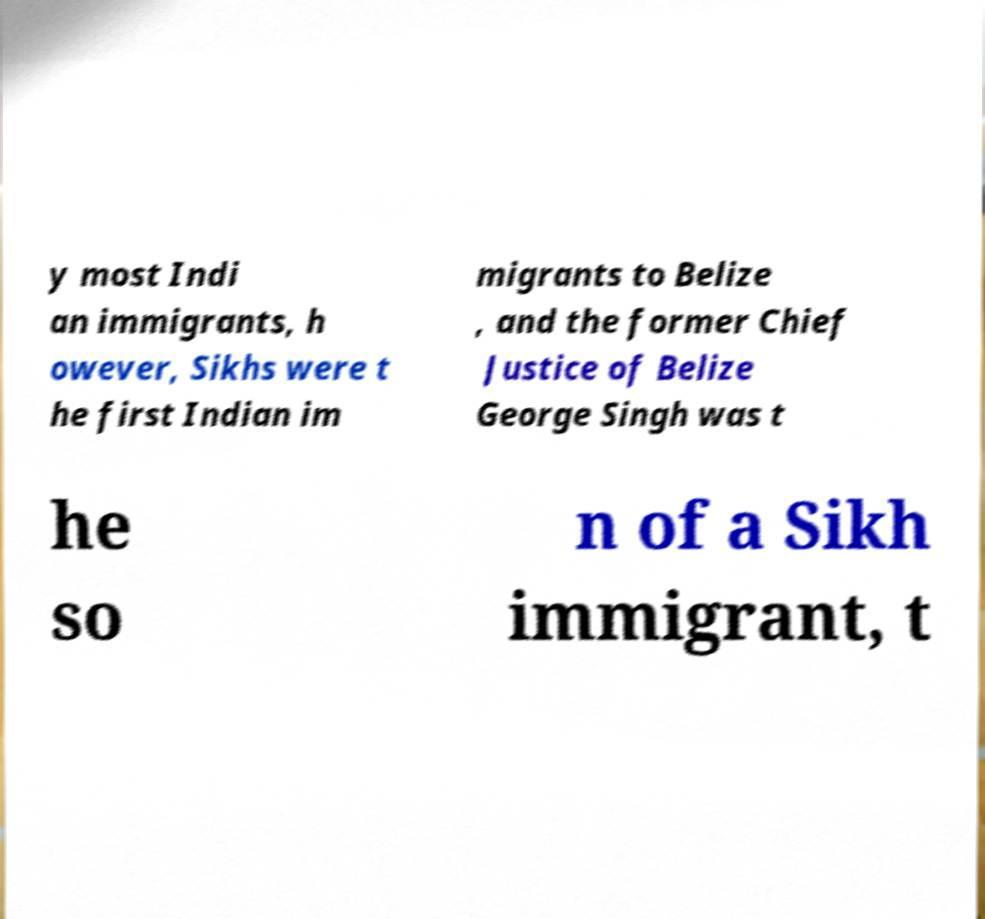Could you assist in decoding the text presented in this image and type it out clearly? y most Indi an immigrants, h owever, Sikhs were t he first Indian im migrants to Belize , and the former Chief Justice of Belize George Singh was t he so n of a Sikh immigrant, t 